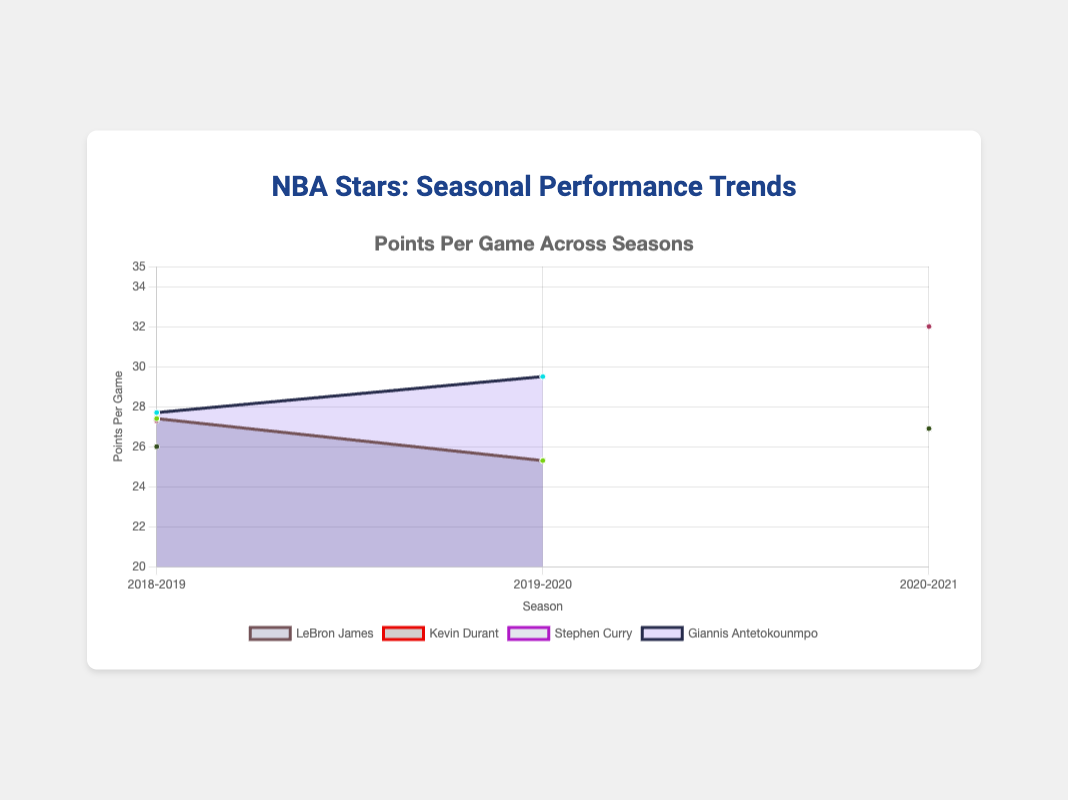How many seasons are displayed in the chart? The chart shows data labels for each season on the x-axis. Counting these labels gives the total number of seasons displayed.
Answer: 4 Which player had the highest points per game in a single season and what was the value? By looking at the highest peak on the chart and identifying the player and the corresponding value of points per game, we find Stephen Curry with 32.0 points per game in the 2020-2021 season.
Answer: Stephen Curry, 32.0 Which player's performance in points per game decreased from one season to the next? By observing the trends for each player, we see a decrease in LeBron James' points per game from the 2018-2019 season to the 2019-2020 season.
Answer: LeBron James How many distinct players' performance trends are shown in the figure? The datasets in the chart represent different players. Counting the unique players listed in the legend will provide the answer.
Answer: 4 Compare the points per game for Giannis Antetokounmpo across his two seasons and identify the difference. Giannis Antetokounmpo scored 27.7 points per game in 2018-2019 and 29.5 in 2019-2020. The difference is computed by subtracting these two values.
Answer: 1.8 Which player had the most consistent points per game across the seasons displayed? By analyzing the slopes of the lines, the player whose line is the flattest (least variation) represents the most consistent performance.
Answer: Kevin Durant What trend can be observed in Stephen Curry's assists per game between the 2018-2019 and 2020-2021 seasons? By noting the values for assists per game in the legend or dataset, we see if the values increased, decreased, or stayed the same. Stephen Curry's assists per game increased from 5.2 to 5.8.
Answer: Increased For the season 2018-2019, which player had the highest rebounding metric? We refer to the metrics listed for each player in season 2018-2019 and pick the highest value for rebounds per game. Giannis Antetokounmpo had 12.5 rebounds per game.
Answer: Giannis Antetokounmpo On average, how many assists per game did LeBron James have across the two seasons shown? The assists per game for LeBron James in the 2018-2019 season are 8.3 and in the 2019-2020 season are 10.2. The average is computed by summing these values and dividing by 2.
Answer: 9.25 